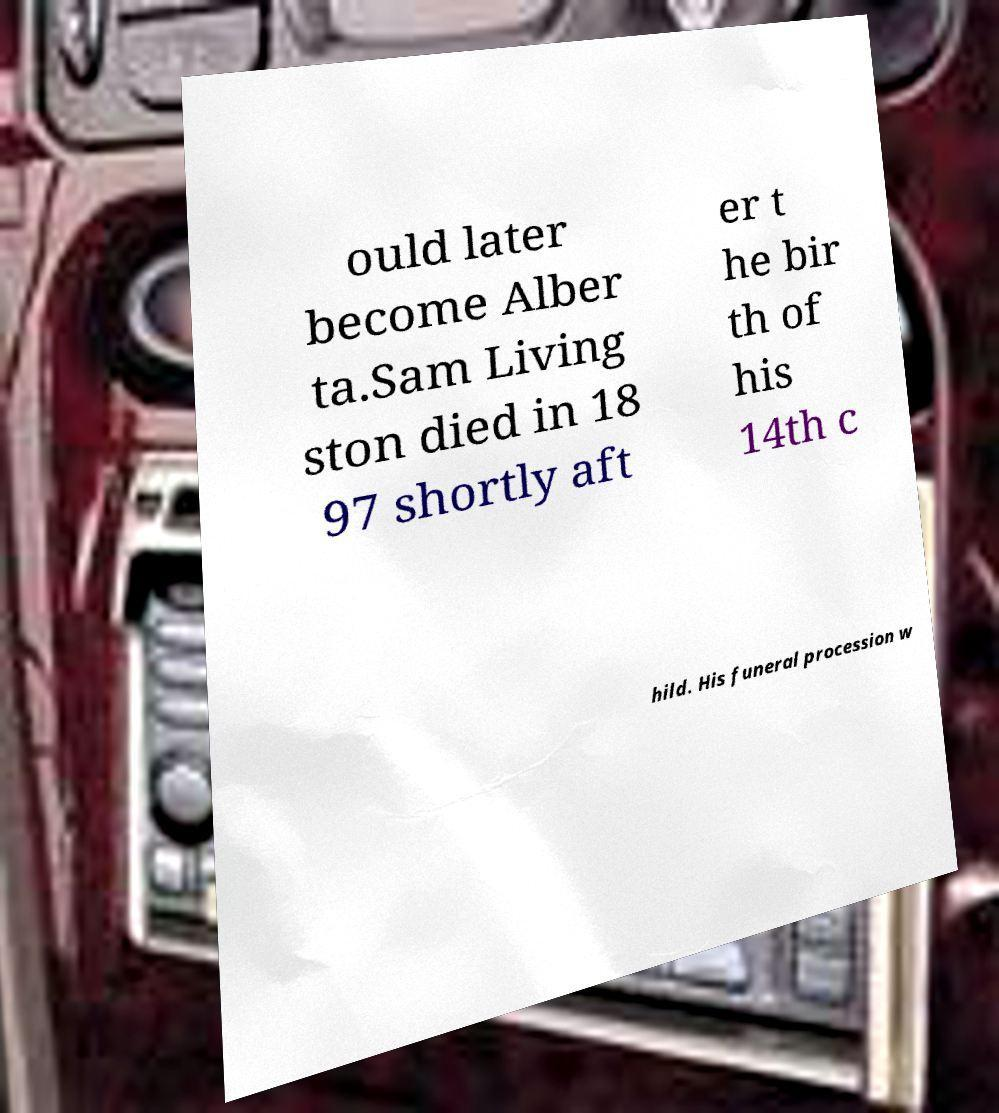Can you read and provide the text displayed in the image?This photo seems to have some interesting text. Can you extract and type it out for me? ould later become Alber ta.Sam Living ston died in 18 97 shortly aft er t he bir th of his 14th c hild. His funeral procession w 